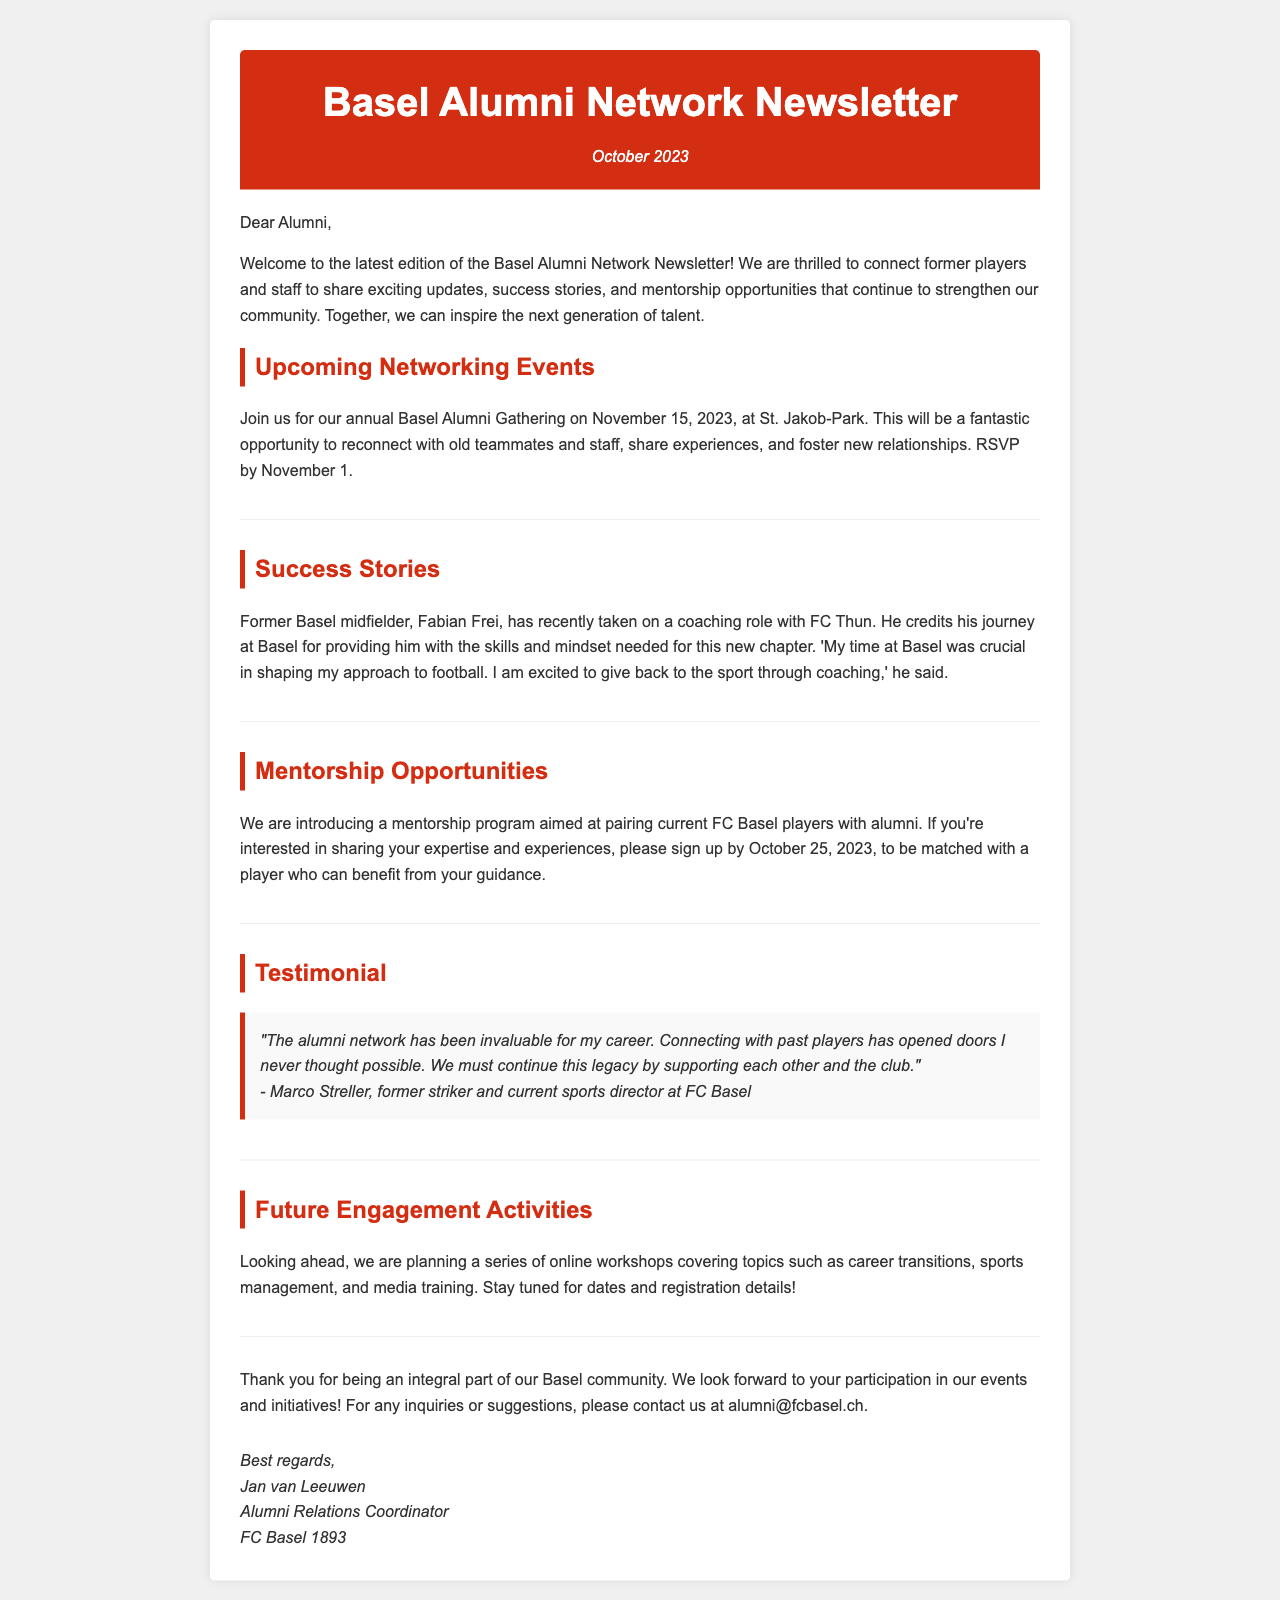What is the date of the Basel Alumni Gathering? The date of the gathering is mentioned in the section about upcoming networking events.
Answer: November 15, 2023 Who is the former Basel midfielder mentioned in the success stories? The success stories section specifically names the former Basel midfielder and shares his new coaching role.
Answer: Fabian Frei What is the deadline to sign up for the mentorship program? The mentorship opportunities section provides a specific date for when interested alumni should sign up.
Answer: October 25, 2023 What is Marco Streller's current position at FC Basel? The testimonial section notes Marco Streller's current role after his playing career.
Answer: Sports director What type of workshops are planned for future engagement? The section on future engagement activities describes the general nature of the upcoming workshops.
Answer: Online workshops 